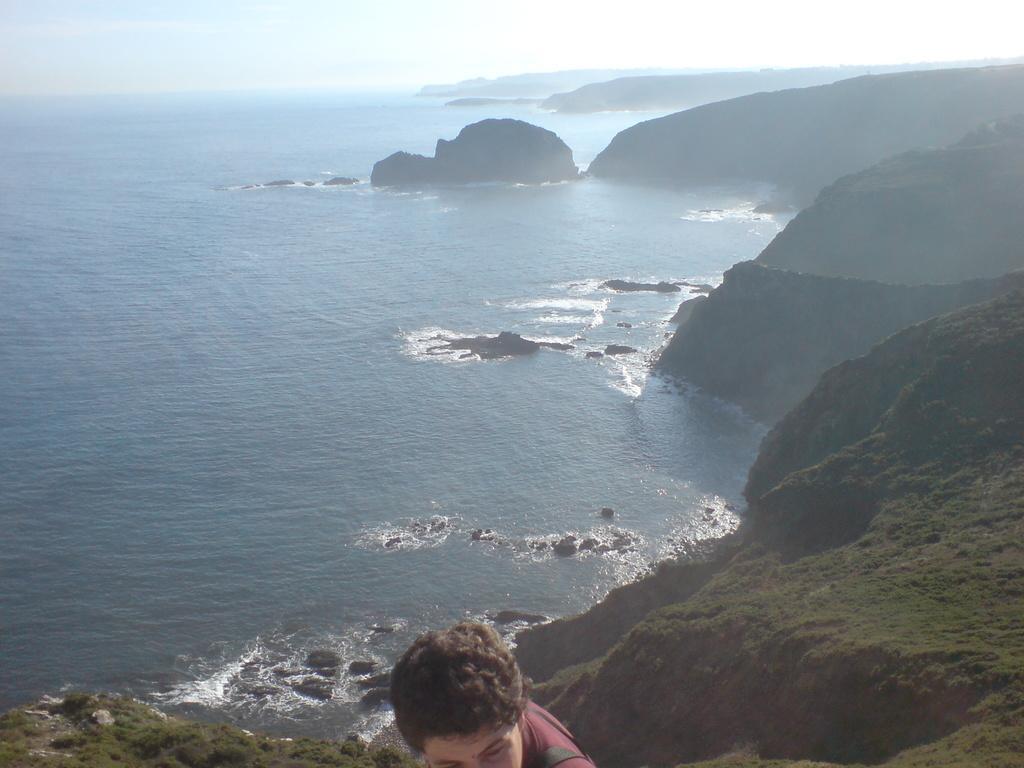Please provide a concise description of this image. In this image I can see the person wearing the maroon color dress. The person is on the rock. To the side of the person I can see the water. In the background I can see the sky. 